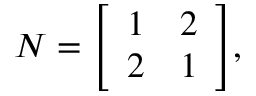<formula> <loc_0><loc_0><loc_500><loc_500>N = { \left [ \begin{array} { l l } { 1 } & { 2 } \\ { 2 } & { 1 } \end{array} \right ] } ,</formula> 